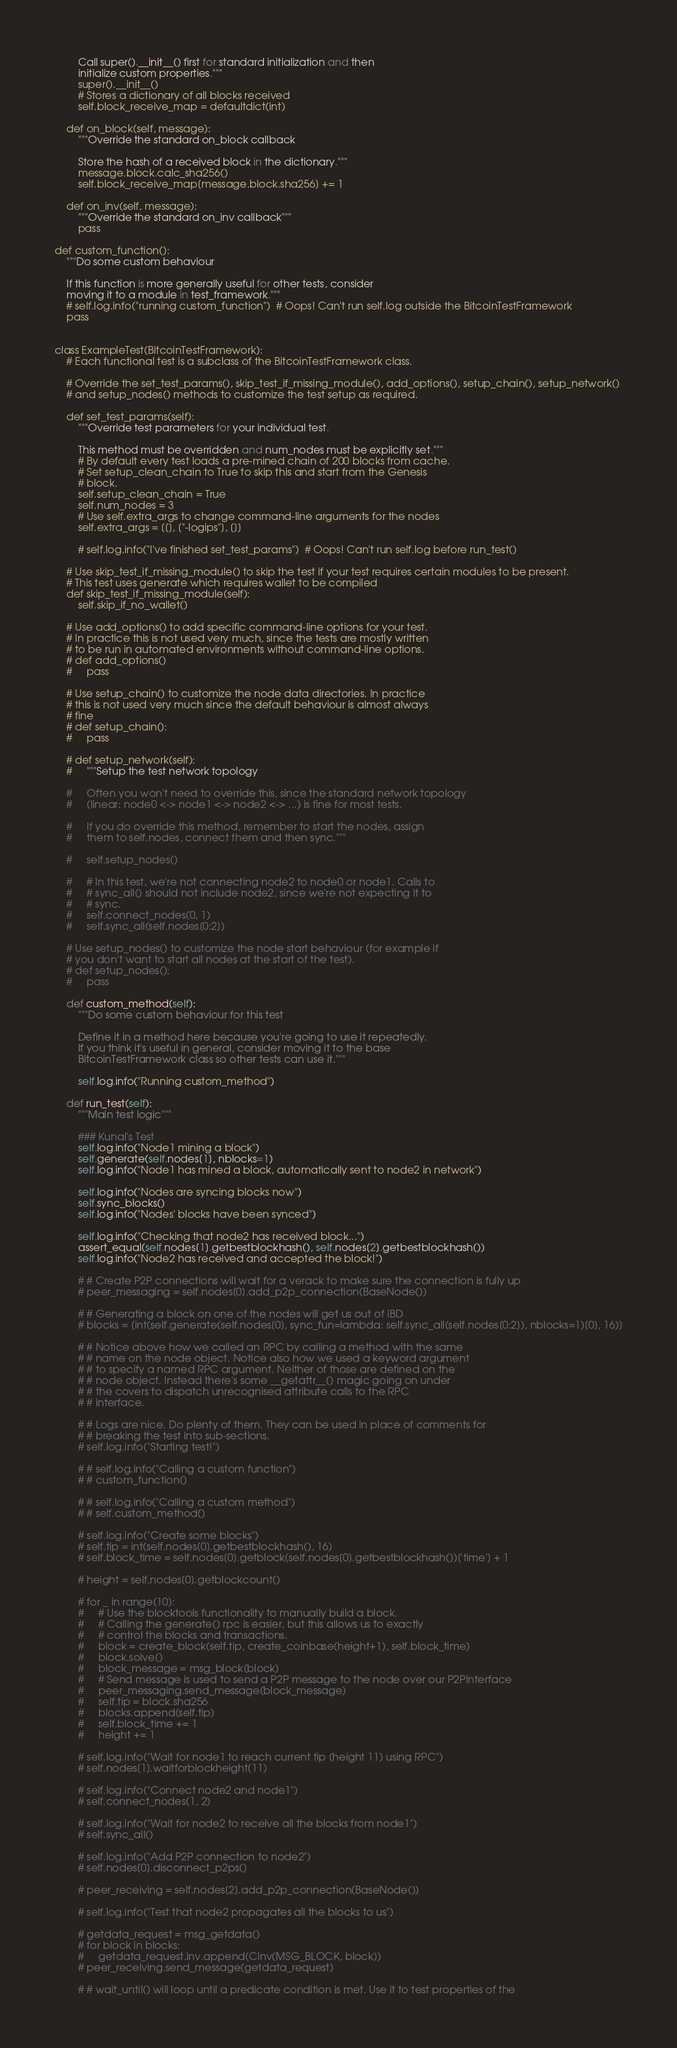Convert code to text. <code><loc_0><loc_0><loc_500><loc_500><_Python_>        Call super().__init__() first for standard initialization and then
        initialize custom properties."""
        super().__init__()
        # Stores a dictionary of all blocks received
        self.block_receive_map = defaultdict(int)

    def on_block(self, message):
        """Override the standard on_block callback

        Store the hash of a received block in the dictionary."""
        message.block.calc_sha256()
        self.block_receive_map[message.block.sha256] += 1

    def on_inv(self, message):
        """Override the standard on_inv callback"""
        pass

def custom_function():
    """Do some custom behaviour

    If this function is more generally useful for other tests, consider
    moving it to a module in test_framework."""
    # self.log.info("running custom_function")  # Oops! Can't run self.log outside the BitcoinTestFramework
    pass


class ExampleTest(BitcoinTestFramework):
    # Each functional test is a subclass of the BitcoinTestFramework class.

    # Override the set_test_params(), skip_test_if_missing_module(), add_options(), setup_chain(), setup_network()
    # and setup_nodes() methods to customize the test setup as required.

    def set_test_params(self):
        """Override test parameters for your individual test.

        This method must be overridden and num_nodes must be explicitly set."""
        # By default every test loads a pre-mined chain of 200 blocks from cache.
        # Set setup_clean_chain to True to skip this and start from the Genesis
        # block.
        self.setup_clean_chain = True
        self.num_nodes = 3
        # Use self.extra_args to change command-line arguments for the nodes
        self.extra_args = [[], ["-logips"], []]

        # self.log.info("I've finished set_test_params")  # Oops! Can't run self.log before run_test()

    # Use skip_test_if_missing_module() to skip the test if your test requires certain modules to be present.
    # This test uses generate which requires wallet to be compiled
    def skip_test_if_missing_module(self):
        self.skip_if_no_wallet()

    # Use add_options() to add specific command-line options for your test.
    # In practice this is not used very much, since the tests are mostly written
    # to be run in automated environments without command-line options.
    # def add_options()
    #     pass

    # Use setup_chain() to customize the node data directories. In practice
    # this is not used very much since the default behaviour is almost always
    # fine
    # def setup_chain():
    #     pass

    # def setup_network(self):
    #     """Setup the test network topology

    #     Often you won't need to override this, since the standard network topology
    #     (linear: node0 <-> node1 <-> node2 <-> ...) is fine for most tests.

    #     If you do override this method, remember to start the nodes, assign
    #     them to self.nodes, connect them and then sync."""

    #     self.setup_nodes()

    #     # In this test, we're not connecting node2 to node0 or node1. Calls to
    #     # sync_all() should not include node2, since we're not expecting it to
    #     # sync.
    #     self.connect_nodes(0, 1)
    #     self.sync_all(self.nodes[0:2])

    # Use setup_nodes() to customize the node start behaviour (for example if
    # you don't want to start all nodes at the start of the test).
    # def setup_nodes():
    #     pass

    def custom_method(self):
        """Do some custom behaviour for this test

        Define it in a method here because you're going to use it repeatedly.
        If you think it's useful in general, consider moving it to the base
        BitcoinTestFramework class so other tests can use it."""

        self.log.info("Running custom_method")

    def run_test(self):
        """Main test logic"""

        ### Kunal's Test
        self.log.info("Node1 mining a block")
        self.generate(self.nodes[1], nblocks=1)
        self.log.info("Node1 has mined a block, automatically sent to node2 in network")
        
        self.log.info("Nodes are syncing blocks now")
        self.sync_blocks()
        self.log.info("Nodes' blocks have been synced")
        
        self.log.info("Checking that node2 has received block...")
        assert_equal(self.nodes[1].getbestblockhash(), self.nodes[2].getbestblockhash())
        self.log.info("Node2 has received and accepted the block!")
        
        # # Create P2P connections will wait for a verack to make sure the connection is fully up
        # peer_messaging = self.nodes[0].add_p2p_connection(BaseNode())

        # # Generating a block on one of the nodes will get us out of IBD
        # blocks = [int(self.generate(self.nodes[0], sync_fun=lambda: self.sync_all(self.nodes[0:2]), nblocks=1)[0], 16)]

        # # Notice above how we called an RPC by calling a method with the same
        # # name on the node object. Notice also how we used a keyword argument
        # # to specify a named RPC argument. Neither of those are defined on the
        # # node object. Instead there's some __getattr__() magic going on under
        # # the covers to dispatch unrecognised attribute calls to the RPC
        # # interface.

        # # Logs are nice. Do plenty of them. They can be used in place of comments for
        # # breaking the test into sub-sections.
        # self.log.info("Starting test!")

        # # self.log.info("Calling a custom function")
        # # custom_function()

        # # self.log.info("Calling a custom method")
        # # self.custom_method()

        # self.log.info("Create some blocks")
        # self.tip = int(self.nodes[0].getbestblockhash(), 16)
        # self.block_time = self.nodes[0].getblock(self.nodes[0].getbestblockhash())['time'] + 1

        # height = self.nodes[0].getblockcount()

        # for _ in range(10):
        #     # Use the blocktools functionality to manually build a block.
        #     # Calling the generate() rpc is easier, but this allows us to exactly
        #     # control the blocks and transactions.
        #     block = create_block(self.tip, create_coinbase(height+1), self.block_time)
        #     block.solve()
        #     block_message = msg_block(block)
        #     # Send message is used to send a P2P message to the node over our P2PInterface
        #     peer_messaging.send_message(block_message)
        #     self.tip = block.sha256
        #     blocks.append(self.tip)
        #     self.block_time += 1
        #     height += 1

        # self.log.info("Wait for node1 to reach current tip (height 11) using RPC")
        # self.nodes[1].waitforblockheight(11)

        # self.log.info("Connect node2 and node1")
        # self.connect_nodes(1, 2)

        # self.log.info("Wait for node2 to receive all the blocks from node1")
        # self.sync_all()

        # self.log.info("Add P2P connection to node2")
        # self.nodes[0].disconnect_p2ps()

        # peer_receiving = self.nodes[2].add_p2p_connection(BaseNode())

        # self.log.info("Test that node2 propagates all the blocks to us")

        # getdata_request = msg_getdata()
        # for block in blocks:
        #     getdata_request.inv.append(CInv(MSG_BLOCK, block))
        # peer_receiving.send_message(getdata_request)

        # # wait_until() will loop until a predicate condition is met. Use it to test properties of the</code> 